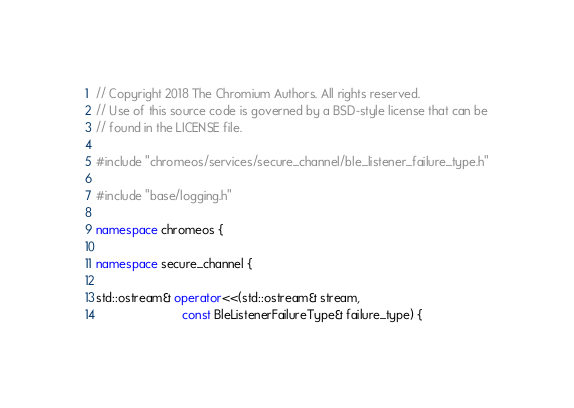<code> <loc_0><loc_0><loc_500><loc_500><_C++_>// Copyright 2018 The Chromium Authors. All rights reserved.
// Use of this source code is governed by a BSD-style license that can be
// found in the LICENSE file.

#include "chromeos/services/secure_channel/ble_listener_failure_type.h"

#include "base/logging.h"

namespace chromeos {

namespace secure_channel {

std::ostream& operator<<(std::ostream& stream,
                         const BleListenerFailureType& failure_type) {</code> 